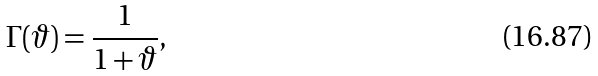Convert formula to latex. <formula><loc_0><loc_0><loc_500><loc_500>\Gamma ( \vartheta ) = \frac { 1 } { 1 + \vartheta } ,</formula> 